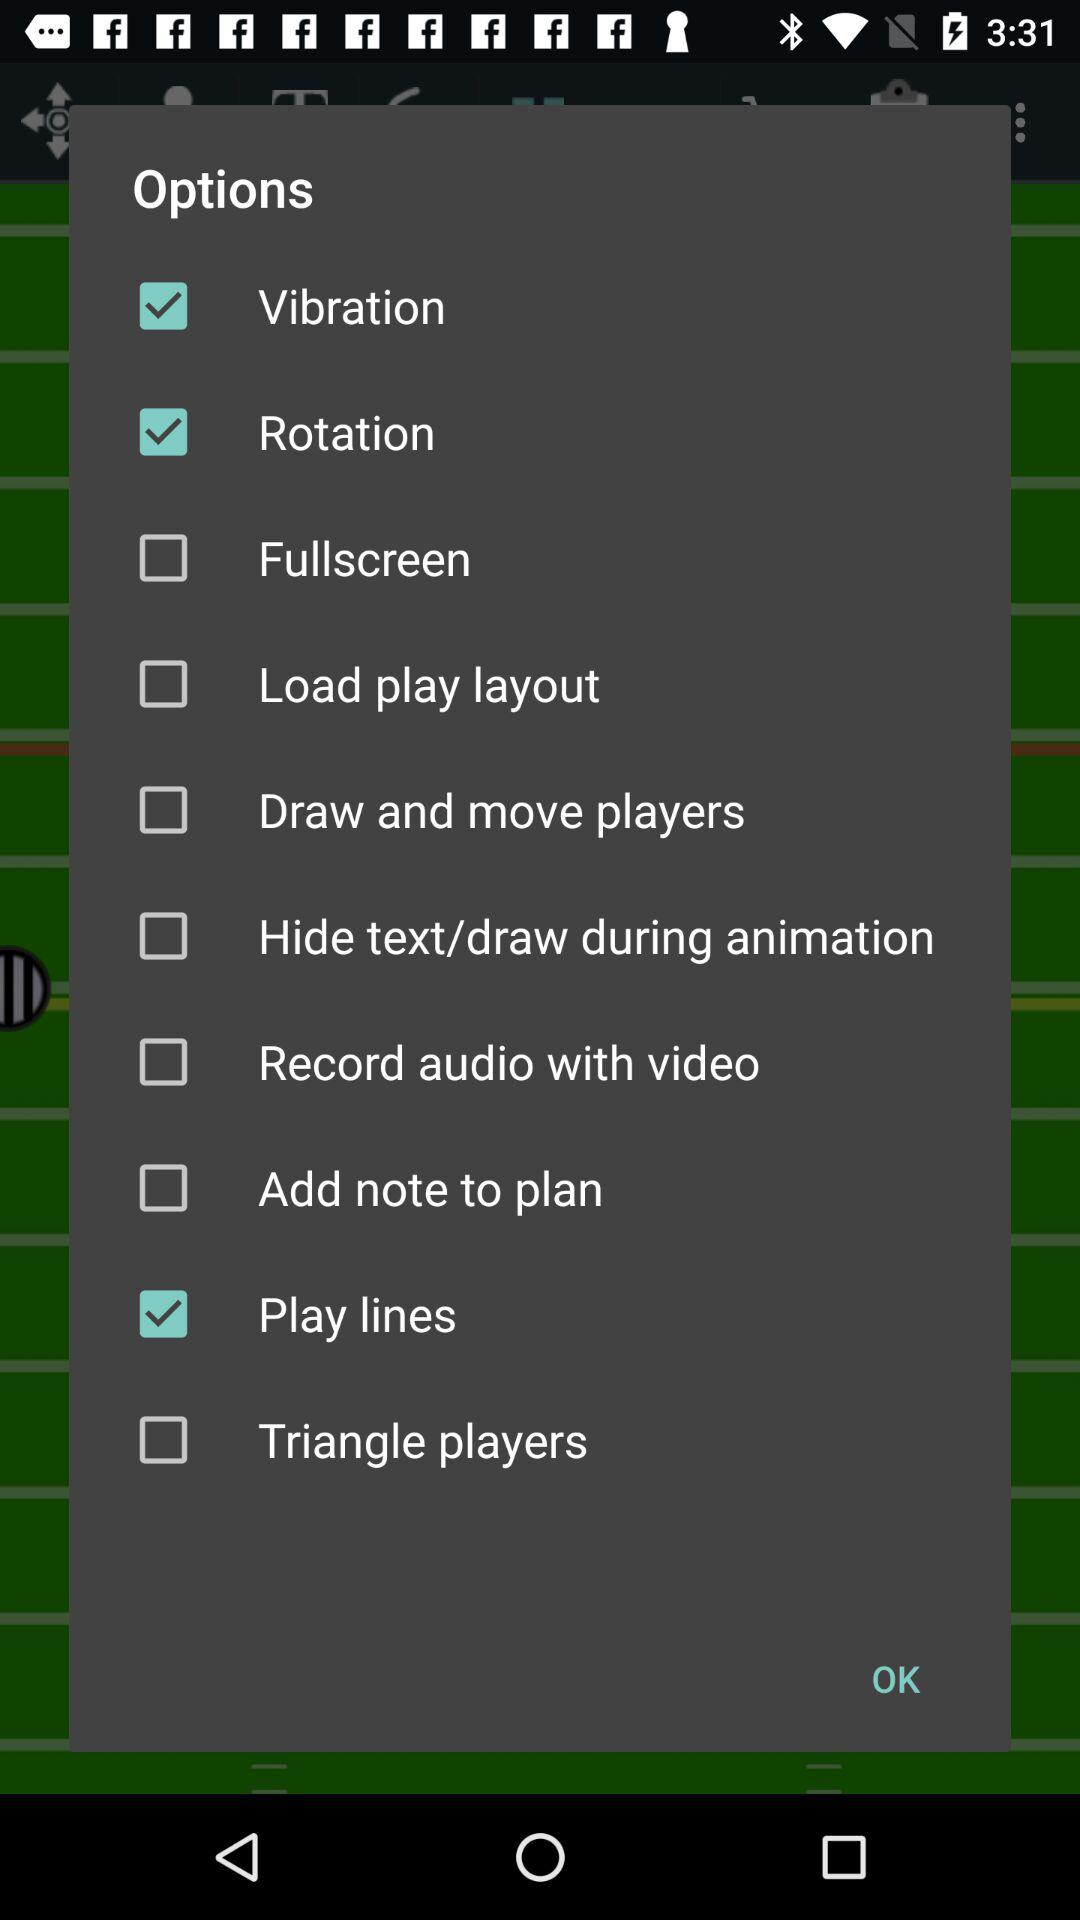Which options have been selected? The selected options are "Vibration", "Rotation" and "Play lines". 